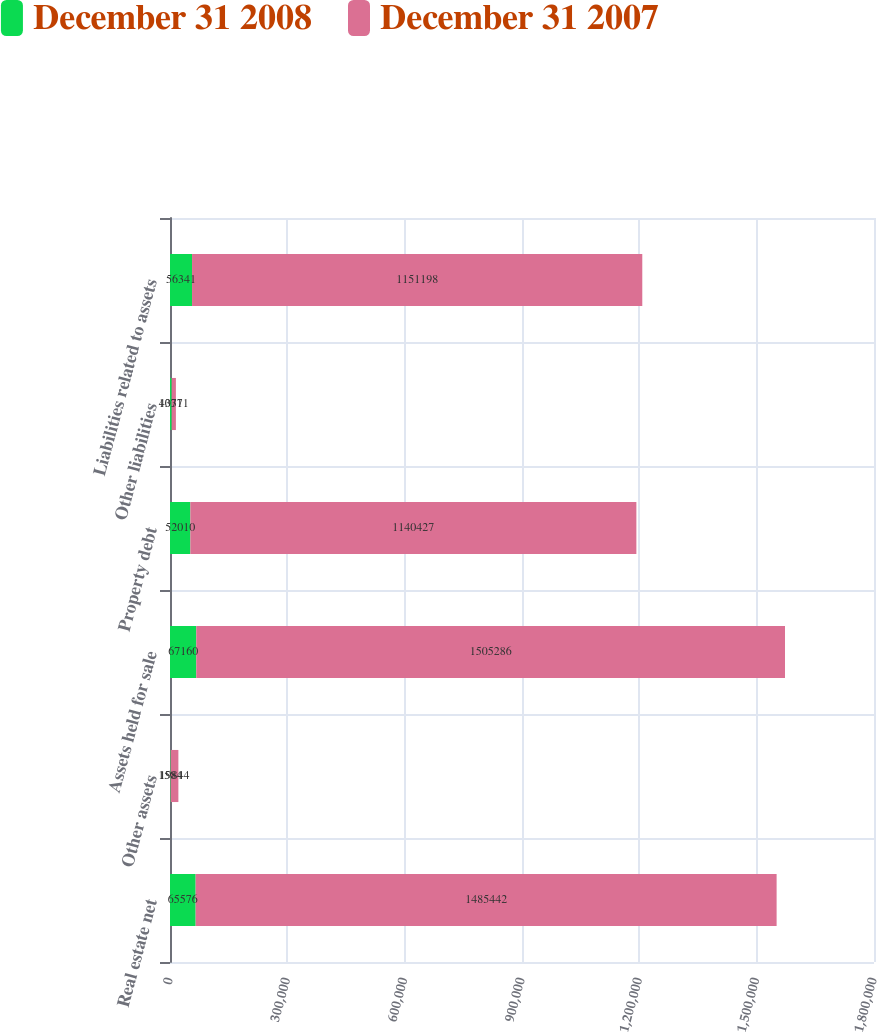<chart> <loc_0><loc_0><loc_500><loc_500><stacked_bar_chart><ecel><fcel>Real estate net<fcel>Other assets<fcel>Assets held for sale<fcel>Property debt<fcel>Other liabilities<fcel>Liabilities related to assets<nl><fcel>December 31 2008<fcel>65576<fcel>1584<fcel>67160<fcel>52010<fcel>4331<fcel>56341<nl><fcel>December 31 2007<fcel>1.48544e+06<fcel>19844<fcel>1.50529e+06<fcel>1.14043e+06<fcel>10771<fcel>1.1512e+06<nl></chart> 